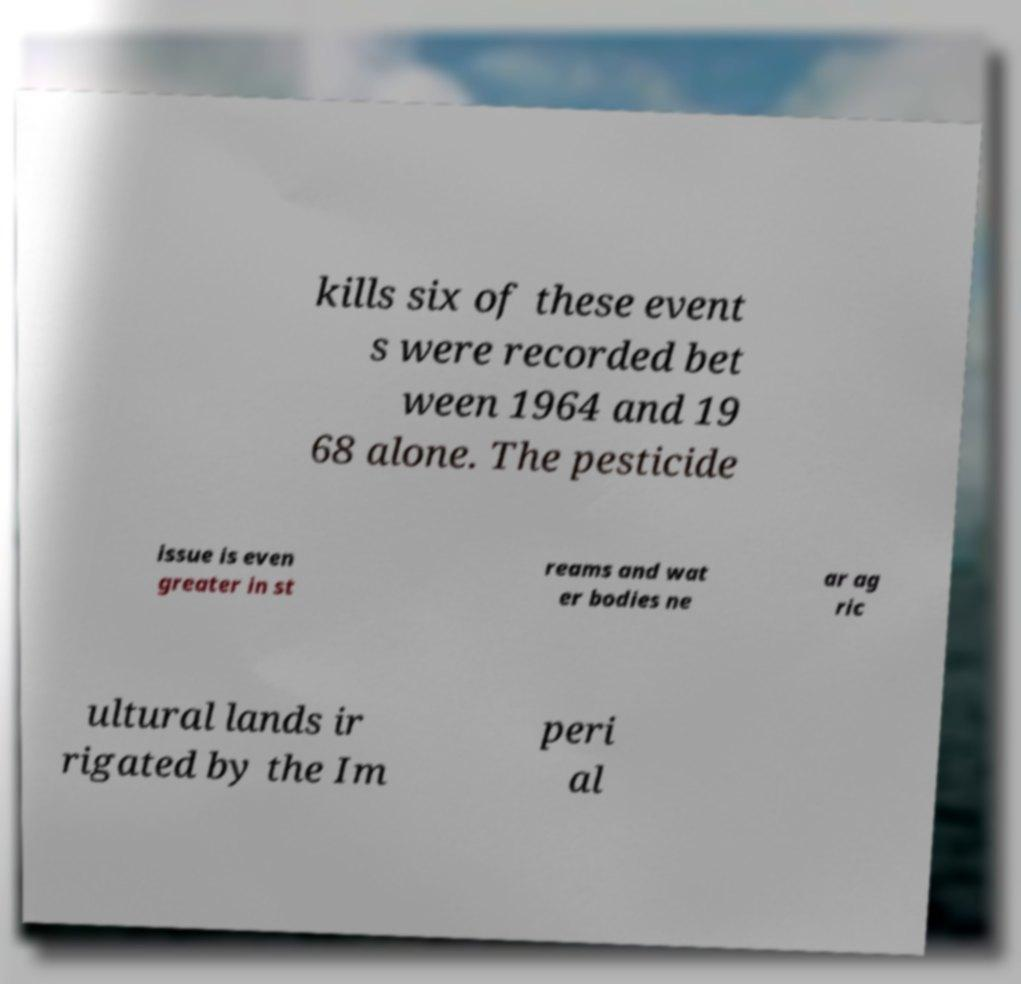I need the written content from this picture converted into text. Can you do that? kills six of these event s were recorded bet ween 1964 and 19 68 alone. The pesticide issue is even greater in st reams and wat er bodies ne ar ag ric ultural lands ir rigated by the Im peri al 